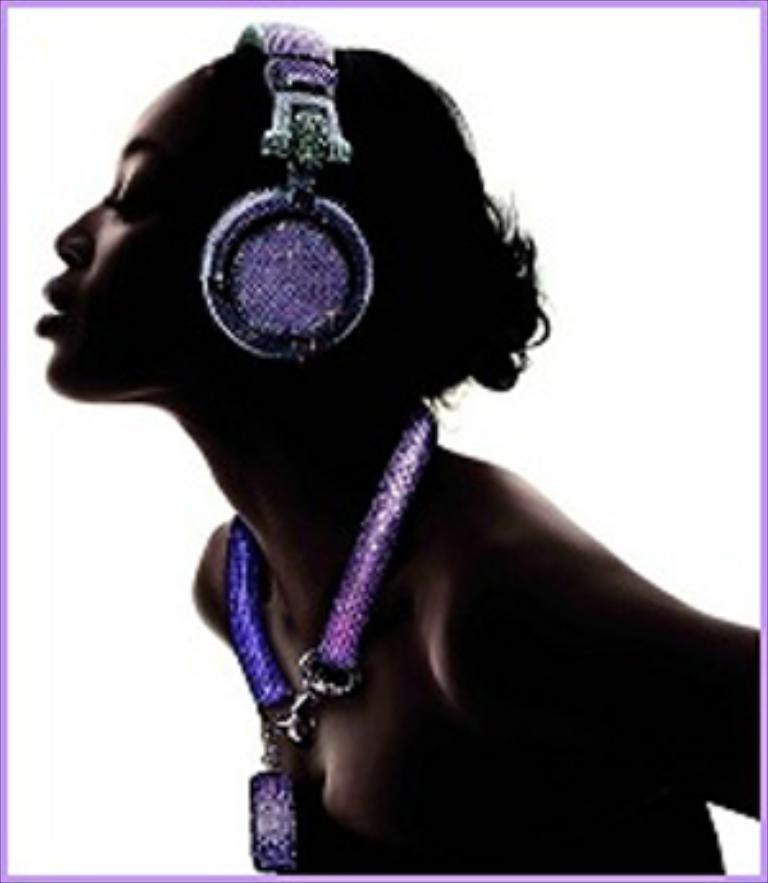What is the main subject of the image? The main subject of the image is a woman. What can be seen on the woman's head in the image? The woman is wearing a headset in the image. What type of cast can be seen on the woman's arm in the image? There is no cast visible on the woman's arm in the image. What is the limit of the woman's ability to lift heavy objects in the image? There is no information about the woman's ability to lift heavy objects in the image. 